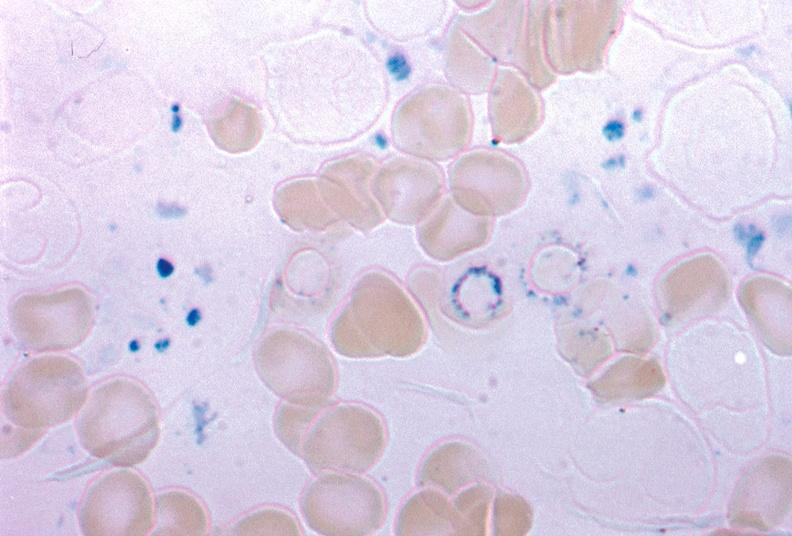does iron stain excellent example source unknown?
Answer the question using a single word or phrase. Yes 